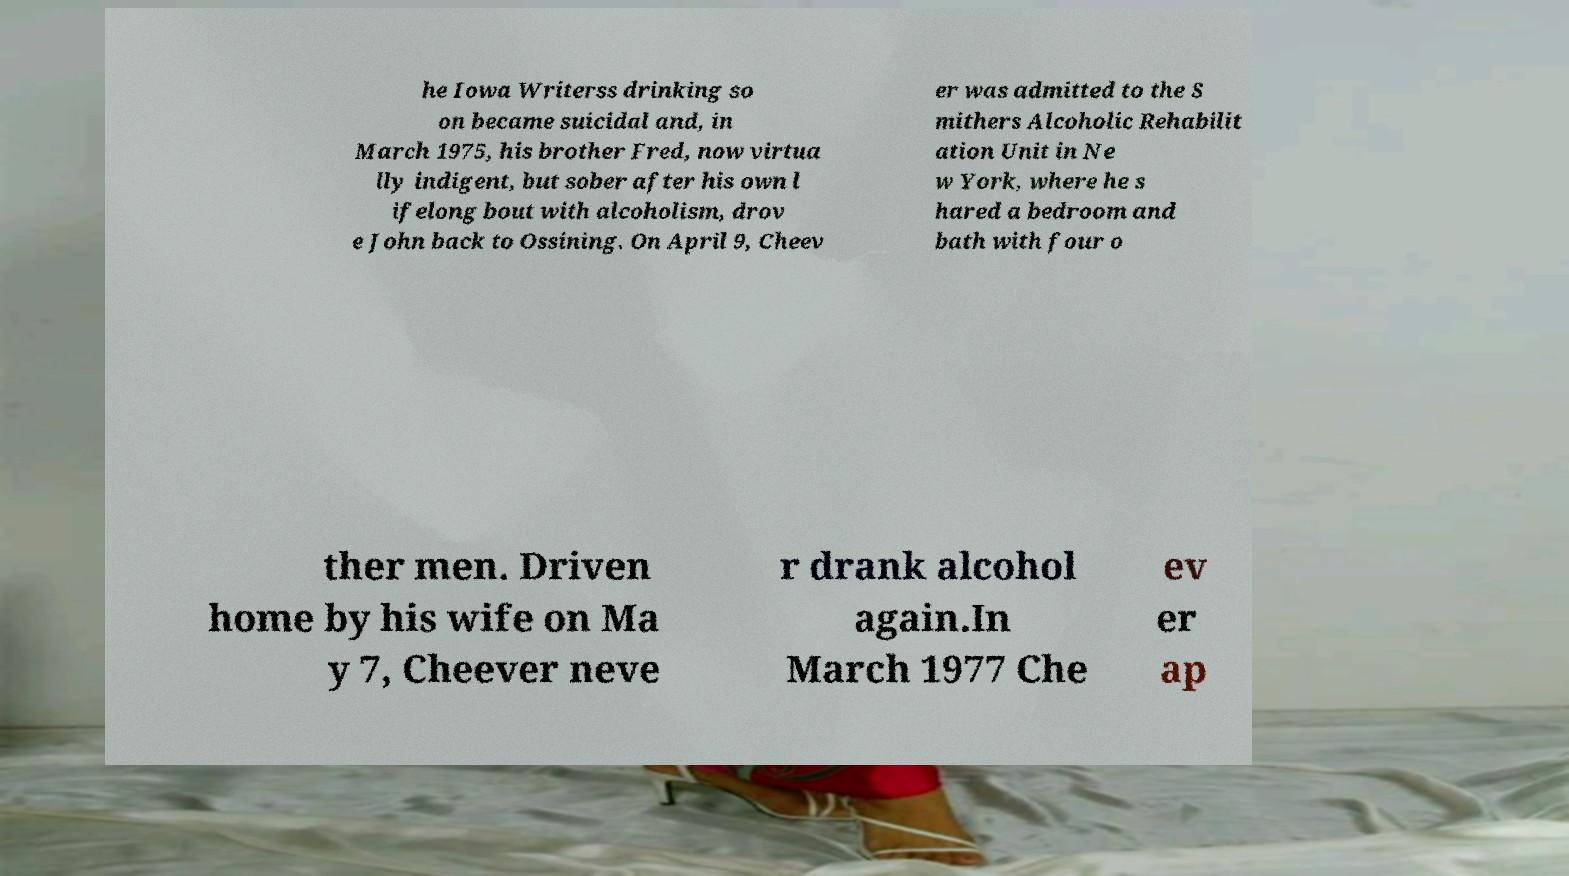What messages or text are displayed in this image? I need them in a readable, typed format. he Iowa Writerss drinking so on became suicidal and, in March 1975, his brother Fred, now virtua lly indigent, but sober after his own l ifelong bout with alcoholism, drov e John back to Ossining. On April 9, Cheev er was admitted to the S mithers Alcoholic Rehabilit ation Unit in Ne w York, where he s hared a bedroom and bath with four o ther men. Driven home by his wife on Ma y 7, Cheever neve r drank alcohol again.In March 1977 Che ev er ap 